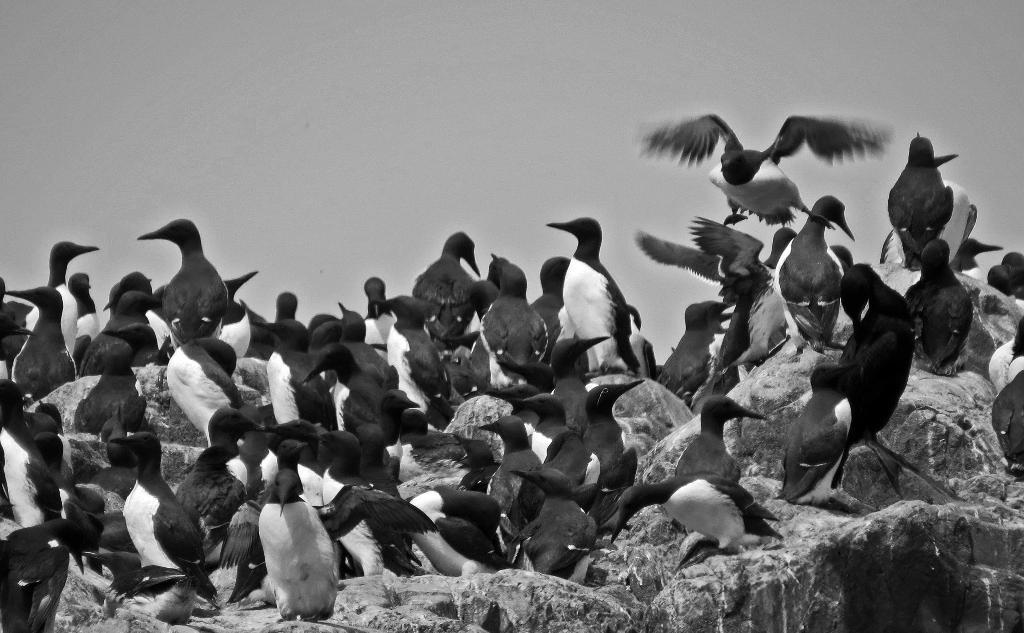What type of animals are present in the image? There is a group of birds in the image. Where are the birds situated? The birds are sitting on a rock surface. Can you describe any other bird-related activity in the image? Yes, there is a bird flying in the image. Where is the flying bird located? The bird is located in the top right corner of the image. What songs are the birds singing in the image? There is no indication in the image that the birds are singing songs, so it cannot be determined from the picture. 